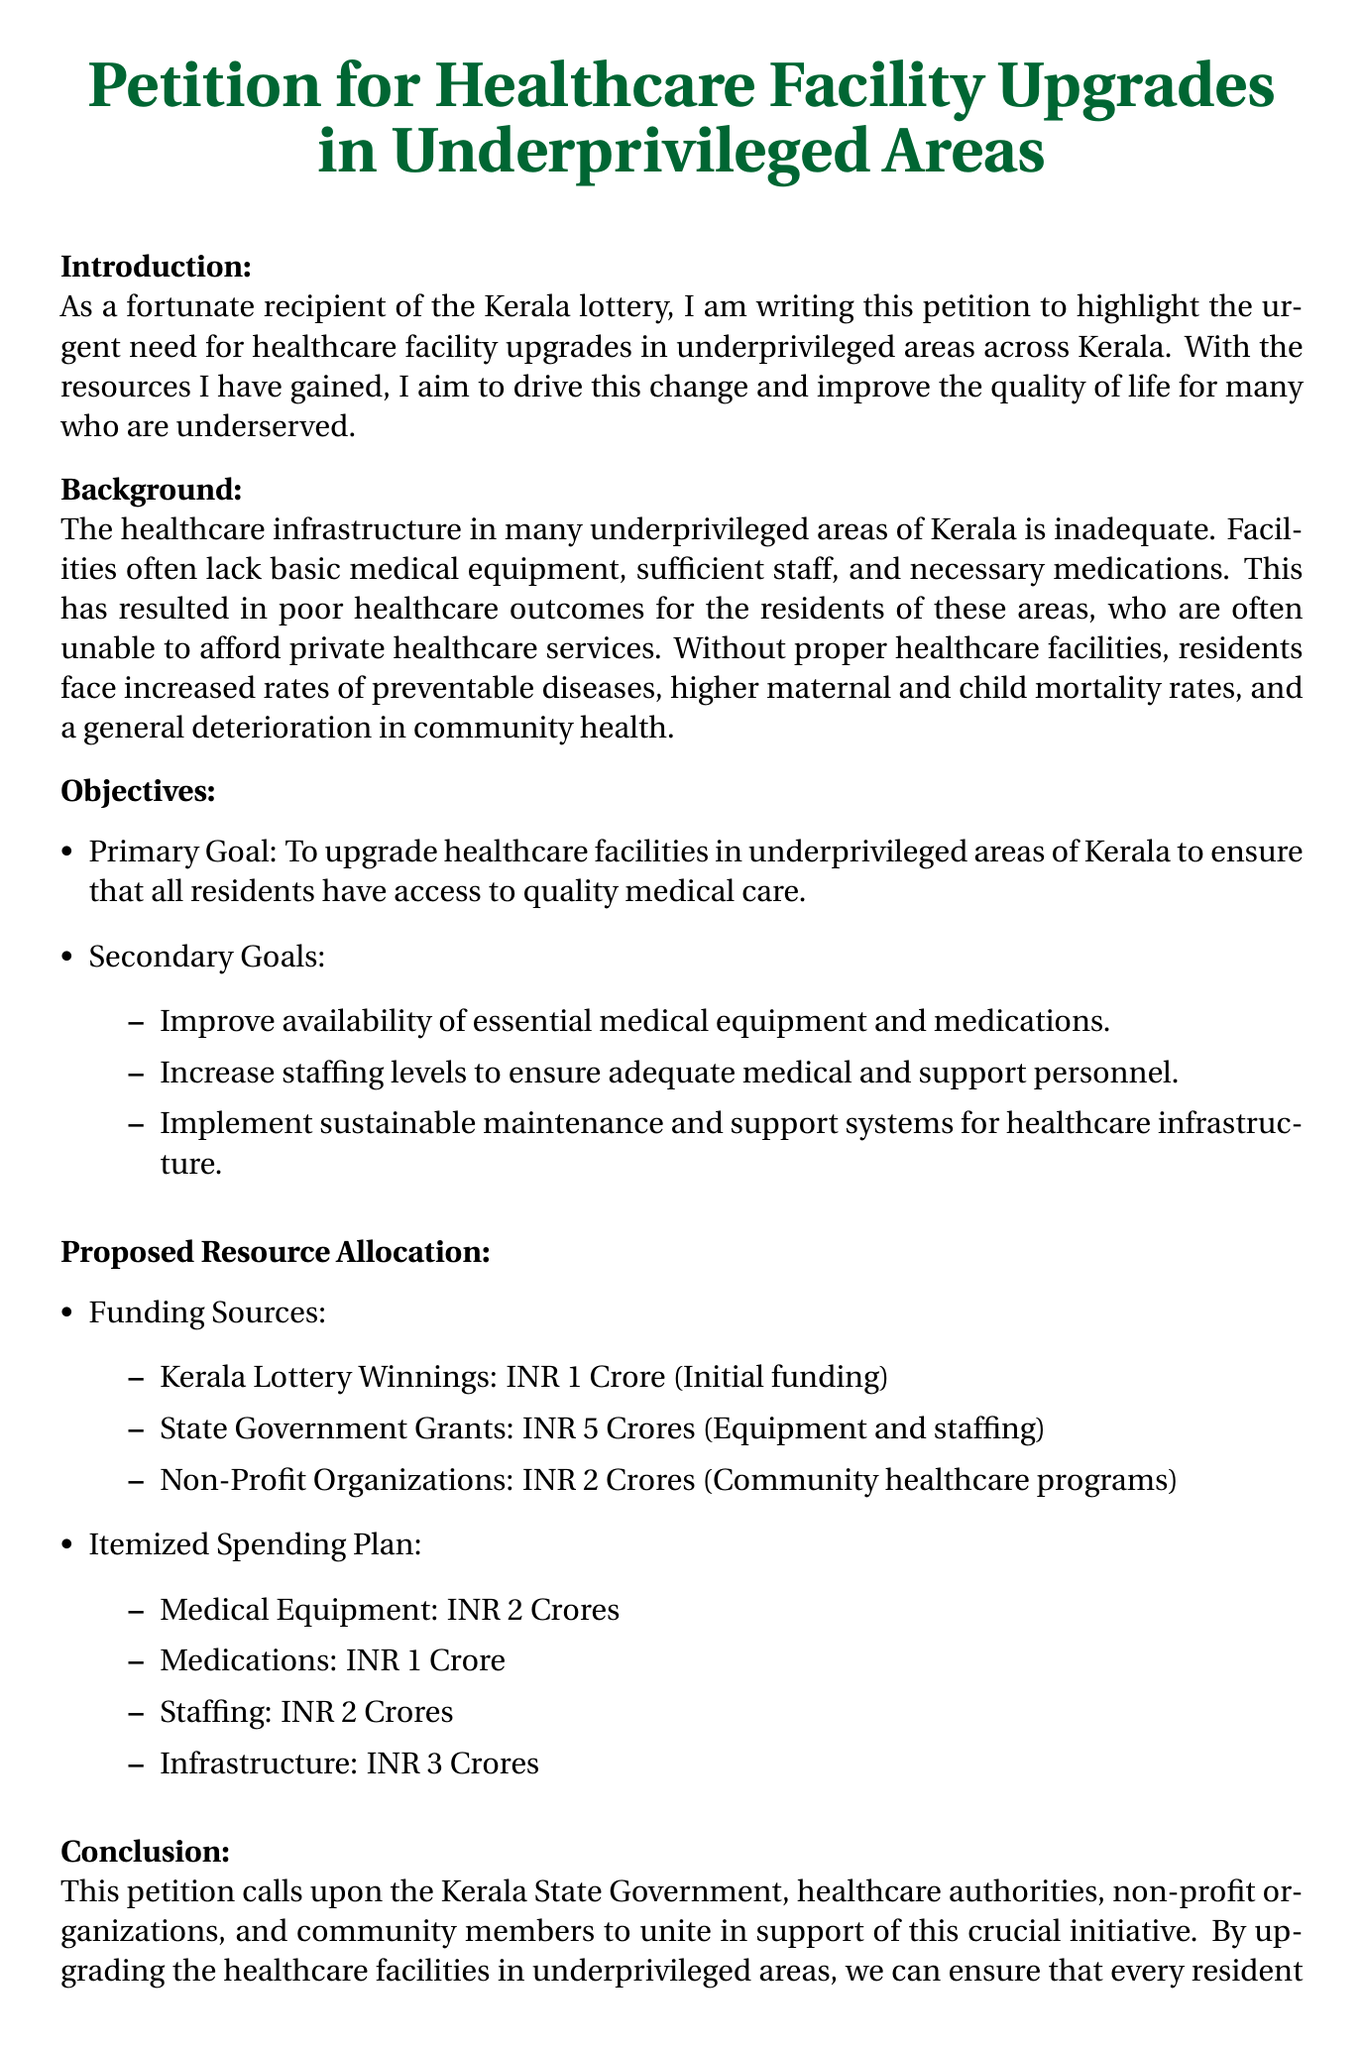What is the main objective of the petition? The main objective is to upgrade healthcare facilities in underprivileged areas of Kerala to ensure that all residents have access to quality medical care.
Answer: Upgrade healthcare facilities How much funding is allocated for medical equipment? The document specifies an itemized spending plan for medical equipment which totals INR 2 Crores.
Answer: INR 2 Crores What is the total amount of Kerala Lottery Winnings mentioned? The petition lists Kerala Lottery winnings as INR 1 Crore, which is part of the funding sources.
Answer: INR 1 Crore What are the secondary goals of the petition? The document outlines several secondary goals, including improving availability of essential medical equipment, increasing staffing levels, and implementing sustainable maintenance systems.
Answer: Improve equipment, increase staffing, implement maintenance How much funding is proposed from non-profit organizations? The document mentions that INR 2 Crores is proposed from non-profit organizations for community healthcare programs.
Answer: INR 2 Crores What is the total amount proposed for infrastructure upgrades? The spending plan indicates that INR 3 Crores is allocated for infrastructure.
Answer: INR 3 Crores Who is the intended audience of this petition? The petition calls upon various groups including the Kerala State Government, healthcare authorities, non-profit organizations, and community members to support the initiative.
Answer: Kerala State Government, healthcare authorities, non-profits, community members What issue does the petition aim to address in underprivileged areas? The petition aims to address the inadequate healthcare infrastructure leading to poor healthcare outcomes in underprivileged areas.
Answer: Inadequate healthcare infrastructure What is the purpose of the resource allocation plan in the petition? The resource allocation plan serves to specify how funds will be utilized to achieve the goals of upgrading healthcare facilities and improving medical services.
Answer: Specify fund utilization 